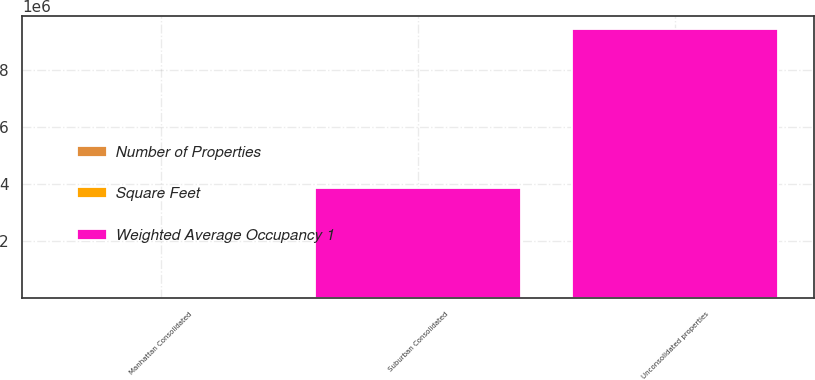Convert chart. <chart><loc_0><loc_0><loc_500><loc_500><stacked_bar_chart><ecel><fcel>Manhattan Consolidated<fcel>Unconsolidated properties<fcel>Suburban Consolidated<nl><fcel>Number of Properties<fcel>21<fcel>8<fcel>25<nl><fcel>Weighted Average Occupancy 1<fcel>89.7<fcel>9.429e+06<fcel>3.863e+06<nl><fcel>Square Feet<fcel>94.6<fcel>95.6<fcel>84.8<nl></chart> 